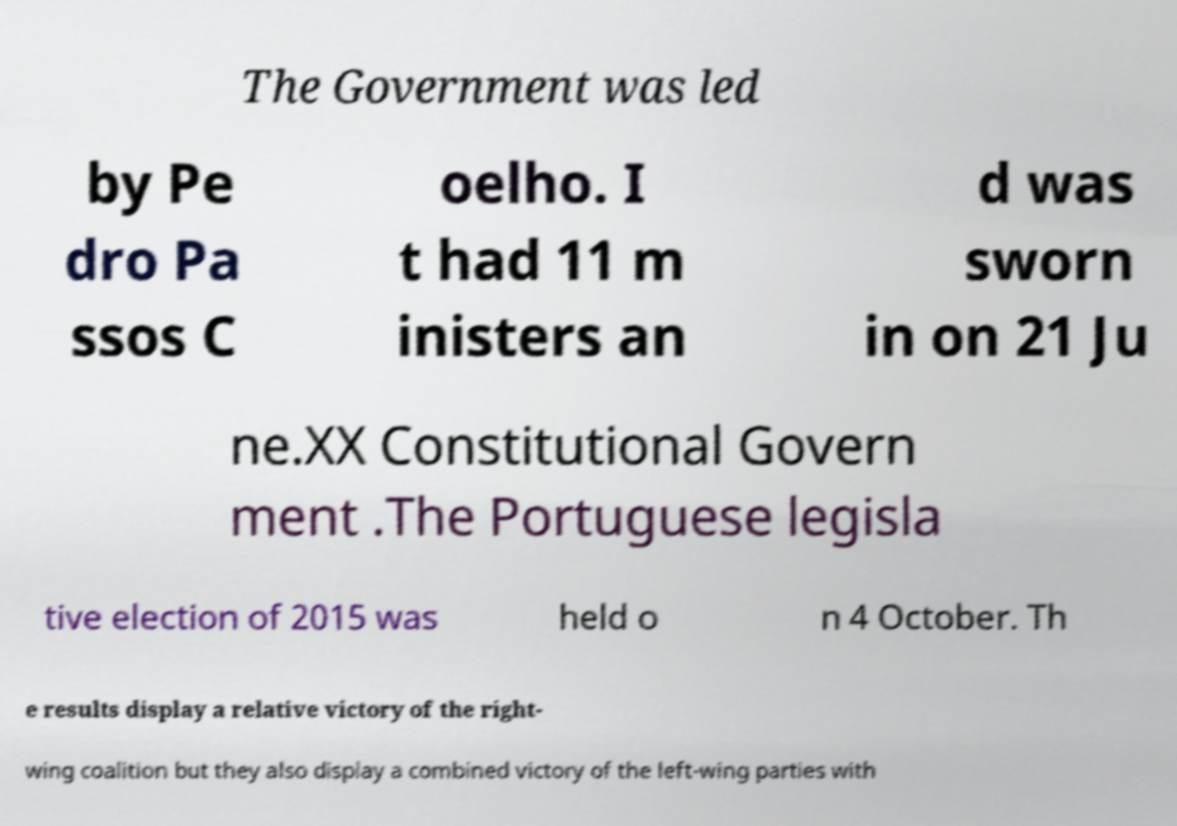For documentation purposes, I need the text within this image transcribed. Could you provide that? The Government was led by Pe dro Pa ssos C oelho. I t had 11 m inisters an d was sworn in on 21 Ju ne.XX Constitutional Govern ment .The Portuguese legisla tive election of 2015 was held o n 4 October. Th e results display a relative victory of the right- wing coalition but they also display a combined victory of the left-wing parties with 